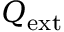<formula> <loc_0><loc_0><loc_500><loc_500>Q _ { e x t }</formula> 